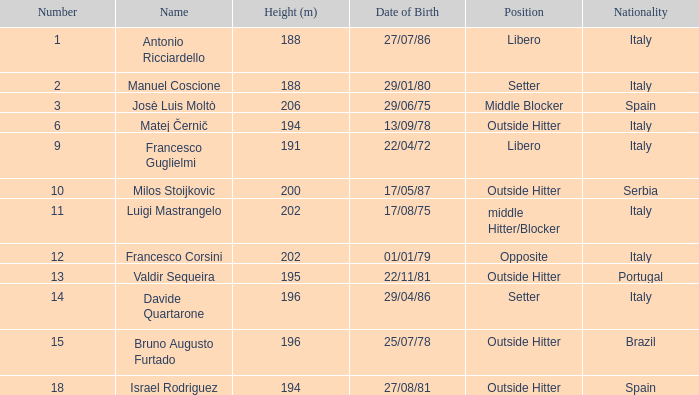Name the least number 1.0. 